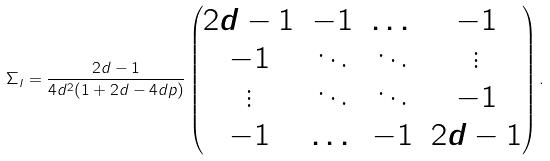Convert formula to latex. <formula><loc_0><loc_0><loc_500><loc_500>\Sigma _ { I } = \frac { 2 d - 1 } { 4 d ^ { 2 } ( 1 + 2 d - 4 d p ) } \begin{pmatrix} 2 d - 1 & - 1 & \dots & - 1 \\ - 1 & \ddots & \ddots & \vdots \\ \vdots & \ddots & \ddots & - 1 \\ - 1 & \dots & - 1 & 2 d - 1 \end{pmatrix} .</formula> 